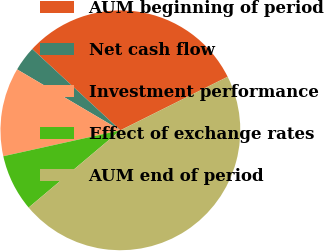<chart> <loc_0><loc_0><loc_500><loc_500><pie_chart><fcel>AUM beginning of period<fcel>Net cash flow<fcel>Investment performance<fcel>Effect of exchange rates<fcel>AUM end of period<nl><fcel>30.77%<fcel>3.38%<fcel>11.95%<fcel>7.67%<fcel>46.23%<nl></chart> 